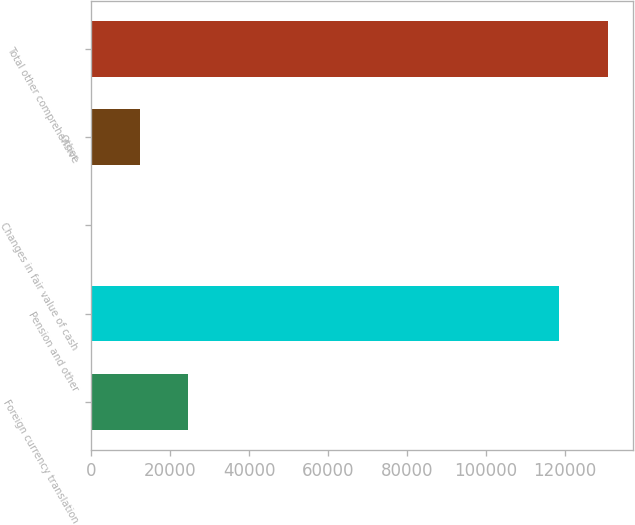Convert chart. <chart><loc_0><loc_0><loc_500><loc_500><bar_chart><fcel>Foreign currency translation<fcel>Pension and other<fcel>Changes in fair value of cash<fcel>Other<fcel>Total other comprehensive<nl><fcel>24565<fcel>118507<fcel>49<fcel>12307<fcel>130765<nl></chart> 